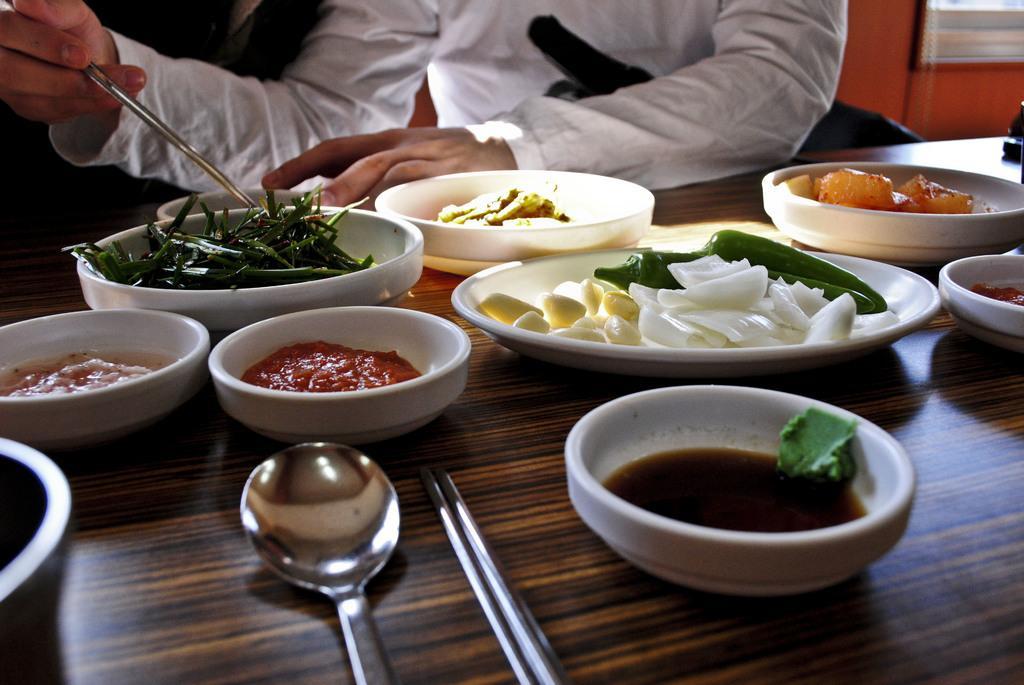Describe this image in one or two sentences. In this picture, we can see a person holding some objects, and we can see table and some objects like plates, bowls with food items in it, spoons, and we can see the wall. 